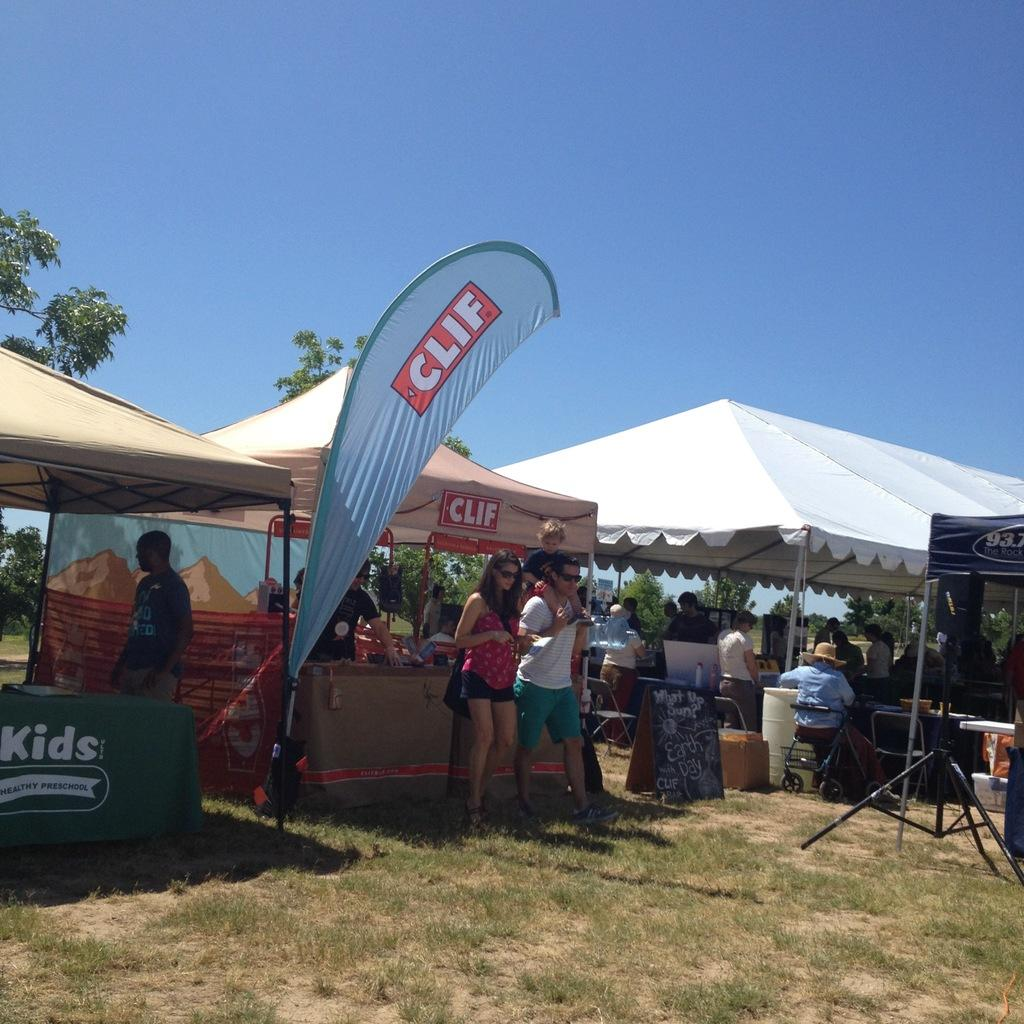What is at the bottom of the image? There is grass and a camera stand at the bottom of the image. What can be seen in the middle of the image? There is a crowd, tents, and trees in the middle of the image. What is visible at the top of the image? The sky is visible at the top of the image. When was the image taken? The image was taken during the day. Can you see a cow wearing a crown in the image? There is no cow or crown present in the image. Is there a party happening in the middle of the image? There is no indication of a party in the image; it features a crowd, tents, and trees. 